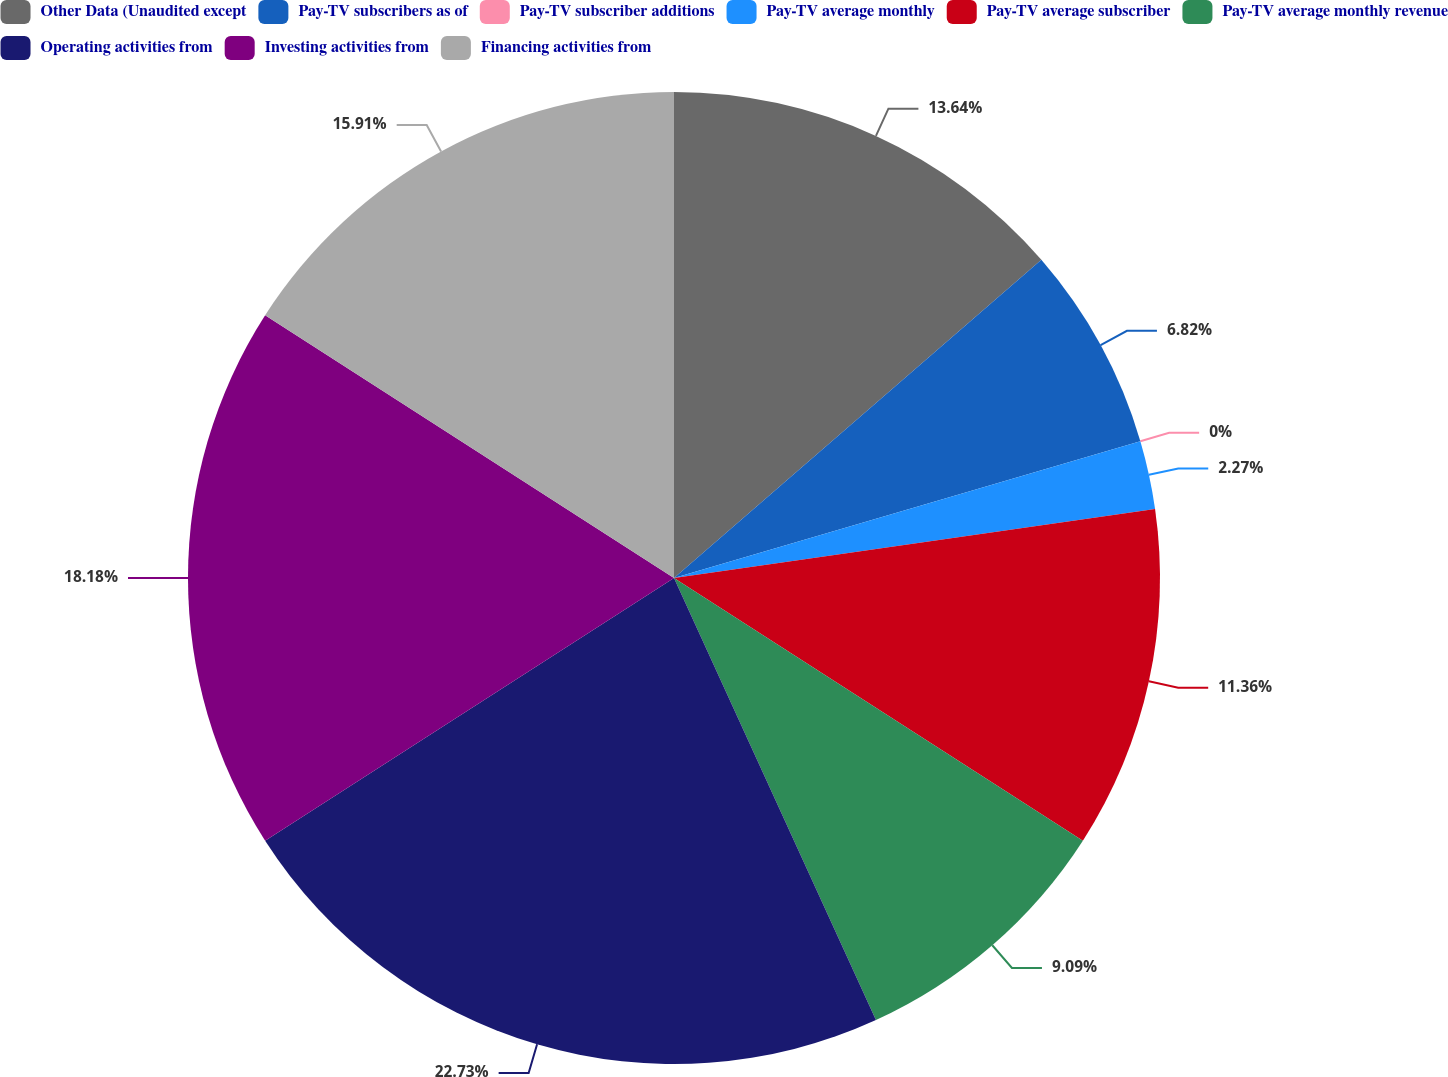Convert chart. <chart><loc_0><loc_0><loc_500><loc_500><pie_chart><fcel>Other Data (Unaudited except<fcel>Pay-TV subscribers as of<fcel>Pay-TV subscriber additions<fcel>Pay-TV average monthly<fcel>Pay-TV average subscriber<fcel>Pay-TV average monthly revenue<fcel>Operating activities from<fcel>Investing activities from<fcel>Financing activities from<nl><fcel>13.64%<fcel>6.82%<fcel>0.0%<fcel>2.27%<fcel>11.36%<fcel>9.09%<fcel>22.73%<fcel>18.18%<fcel>15.91%<nl></chart> 